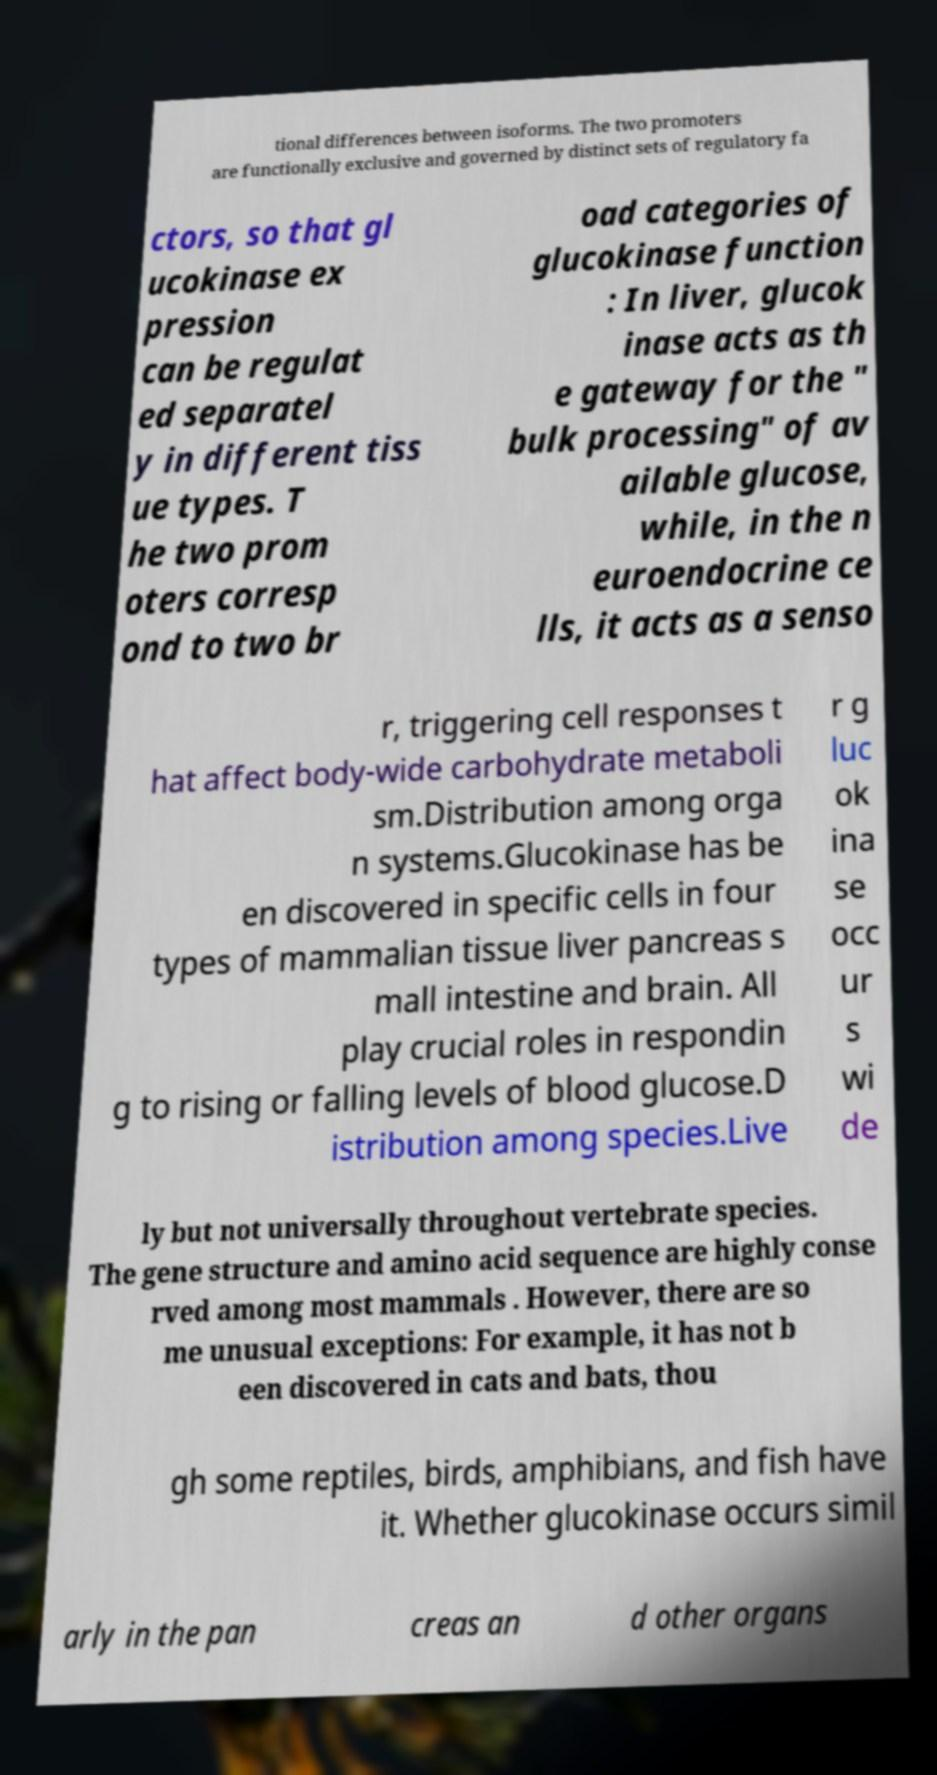What messages or text are displayed in this image? I need them in a readable, typed format. tional differences between isoforms. The two promoters are functionally exclusive and governed by distinct sets of regulatory fa ctors, so that gl ucokinase ex pression can be regulat ed separatel y in different tiss ue types. T he two prom oters corresp ond to two br oad categories of glucokinase function : In liver, glucok inase acts as th e gateway for the " bulk processing" of av ailable glucose, while, in the n euroendocrine ce lls, it acts as a senso r, triggering cell responses t hat affect body-wide carbohydrate metaboli sm.Distribution among orga n systems.Glucokinase has be en discovered in specific cells in four types of mammalian tissue liver pancreas s mall intestine and brain. All play crucial roles in respondin g to rising or falling levels of blood glucose.D istribution among species.Live r g luc ok ina se occ ur s wi de ly but not universally throughout vertebrate species. The gene structure and amino acid sequence are highly conse rved among most mammals . However, there are so me unusual exceptions: For example, it has not b een discovered in cats and bats, thou gh some reptiles, birds, amphibians, and fish have it. Whether glucokinase occurs simil arly in the pan creas an d other organs 